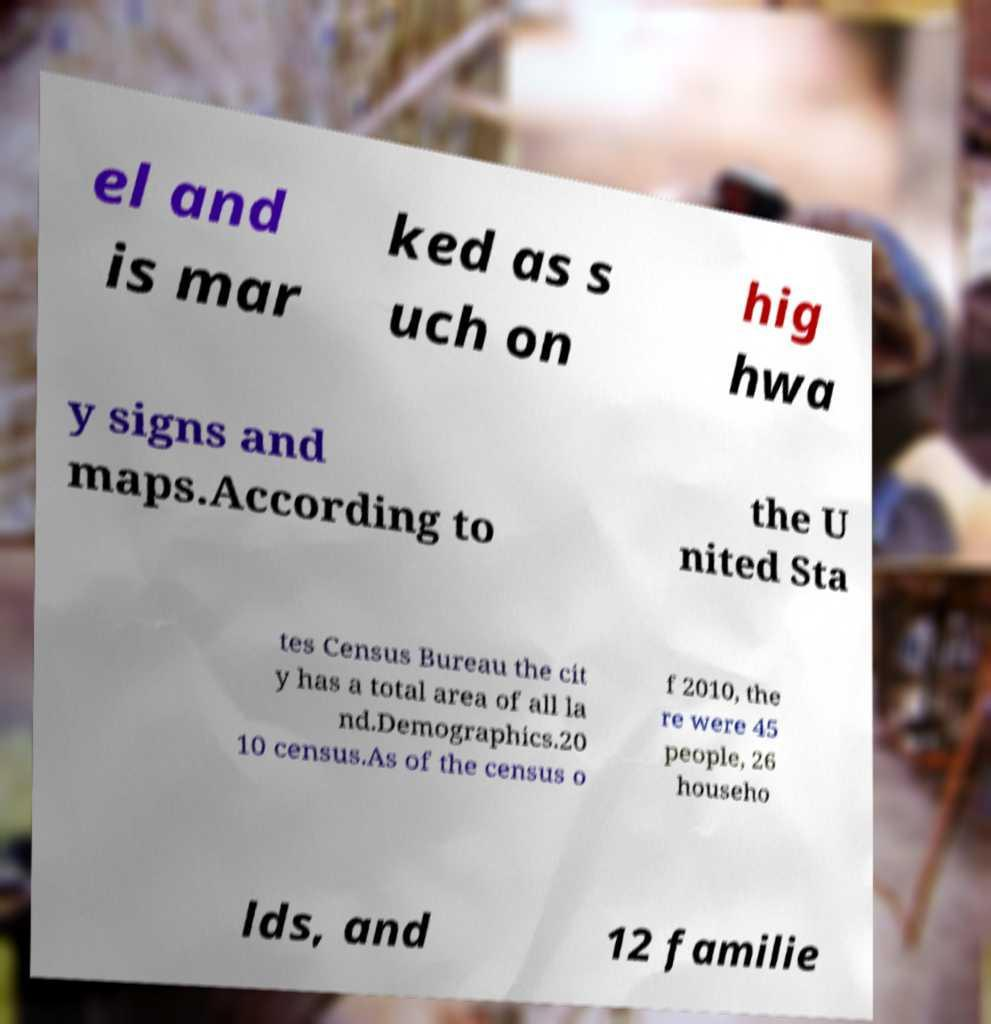There's text embedded in this image that I need extracted. Can you transcribe it verbatim? el and is mar ked as s uch on hig hwa y signs and maps.According to the U nited Sta tes Census Bureau the cit y has a total area of all la nd.Demographics.20 10 census.As of the census o f 2010, the re were 45 people, 26 househo lds, and 12 familie 